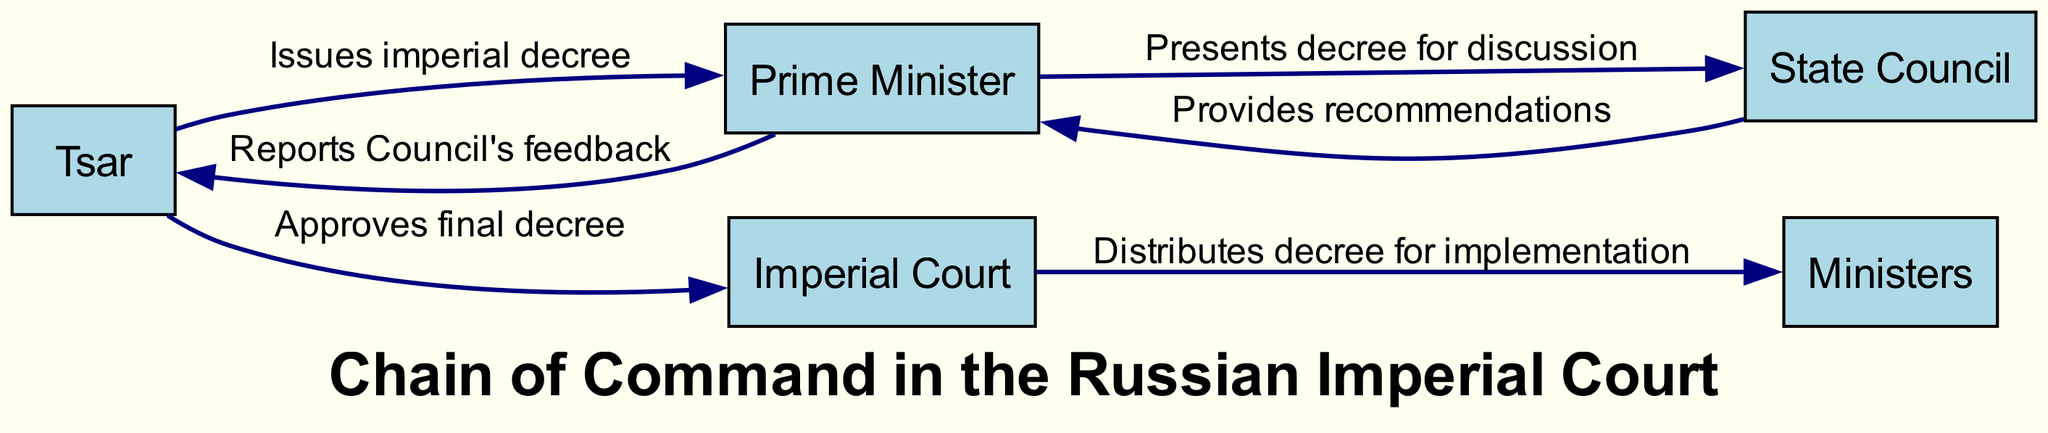What is the first actor in the sequence? The diagram starts with the Tsar as the first actor in the sequence, indicating the top role in the command chain.
Answer: Tsar How many nodes are in the diagram? The diagram contains five unique nodes, representing different levels of the command chain in the Russian Imperial Court.
Answer: 5 What action does the Tsar take towards the Prime Minister? The diagram shows that the Tsar issues an imperial decree to the Prime Minister, indicating a direct action from the top of the hierarchy to the next level.
Answer: Issues imperial decree What action follows the discussion in the State Council? After the Prime Minister presents the decree to the State Council, the next action is that the State Council provides recommendations back to the Prime Minister.
Answer: Provides recommendations What is the last action represented in the sequence? The final action shown in the diagram is the distribution of the decree by the Imperial Court to the ministers for implementation, completing the command chain.
Answer: Distributes decree for implementation Who receives the report after the State Council provides feedback? The Prime Minister is the one who receives the feedback report from the State Council before reporting it back to the Tsar, indicating the flow of information in the hierarchy.
Answer: Prime Minister Which actor is responsible for implementing the decree? The ministers are tasked with implementing the decree as indicated by their position in the sequence of actions following the approval from the Tsar.
Answer: Ministers What sequence leads to the final approval of the decree? The sequence leading to the final approval begins with the Tsar issuing a decree, followed by the discussion in the State Council, recommendations back to the Prime Minister, and then a report to the Tsar before approval.
Answer: Tsar issues decree → State Council discussion → Recommendations → Reports feedback → Approves final decree 